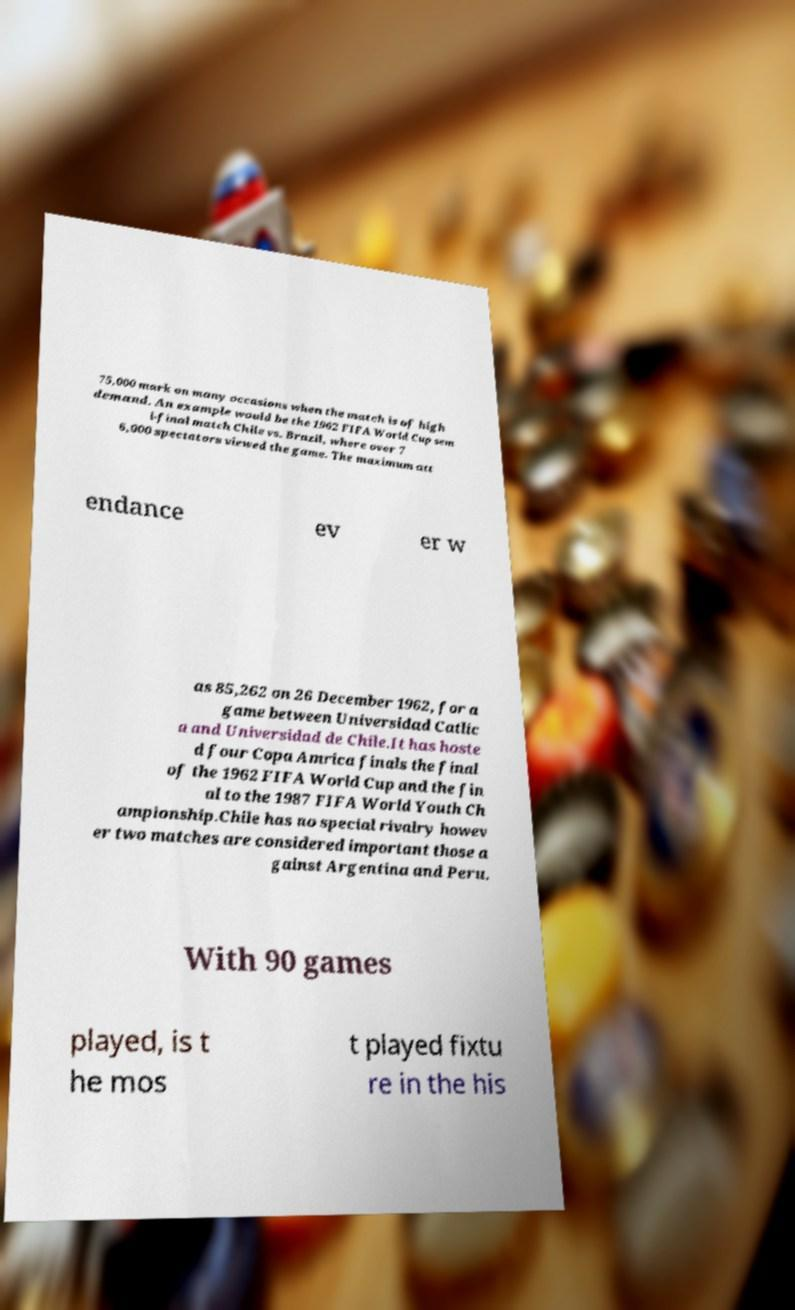I need the written content from this picture converted into text. Can you do that? 75,000 mark on many occasions when the match is of high demand. An example would be the 1962 FIFA World Cup sem i-final match Chile vs. Brazil, where over 7 6,000 spectators viewed the game. The maximum att endance ev er w as 85,262 on 26 December 1962, for a game between Universidad Catlic a and Universidad de Chile.It has hoste d four Copa Amrica finals the final of the 1962 FIFA World Cup and the fin al to the 1987 FIFA World Youth Ch ampionship.Chile has no special rivalry howev er two matches are considered important those a gainst Argentina and Peru. With 90 games played, is t he mos t played fixtu re in the his 